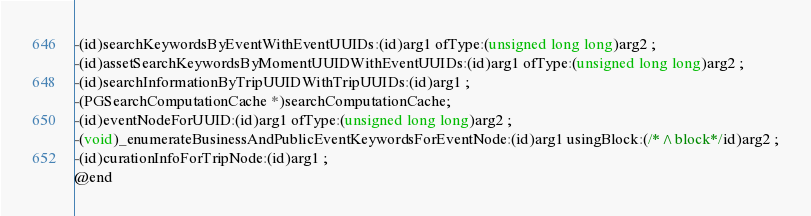<code> <loc_0><loc_0><loc_500><loc_500><_C_>-(id)searchKeywordsByEventWithEventUUIDs:(id)arg1 ofType:(unsigned long long)arg2 ;
-(id)assetSearchKeywordsByMomentUUIDWithEventUUIDs:(id)arg1 ofType:(unsigned long long)arg2 ;
-(id)searchInformationByTripUUIDWithTripUUIDs:(id)arg1 ;
-(PGSearchComputationCache *)searchComputationCache;
-(id)eventNodeForUUID:(id)arg1 ofType:(unsigned long long)arg2 ;
-(void)_enumerateBusinessAndPublicEventKeywordsForEventNode:(id)arg1 usingBlock:(/*^block*/id)arg2 ;
-(id)curationInfoForTripNode:(id)arg1 ;
@end

</code> 